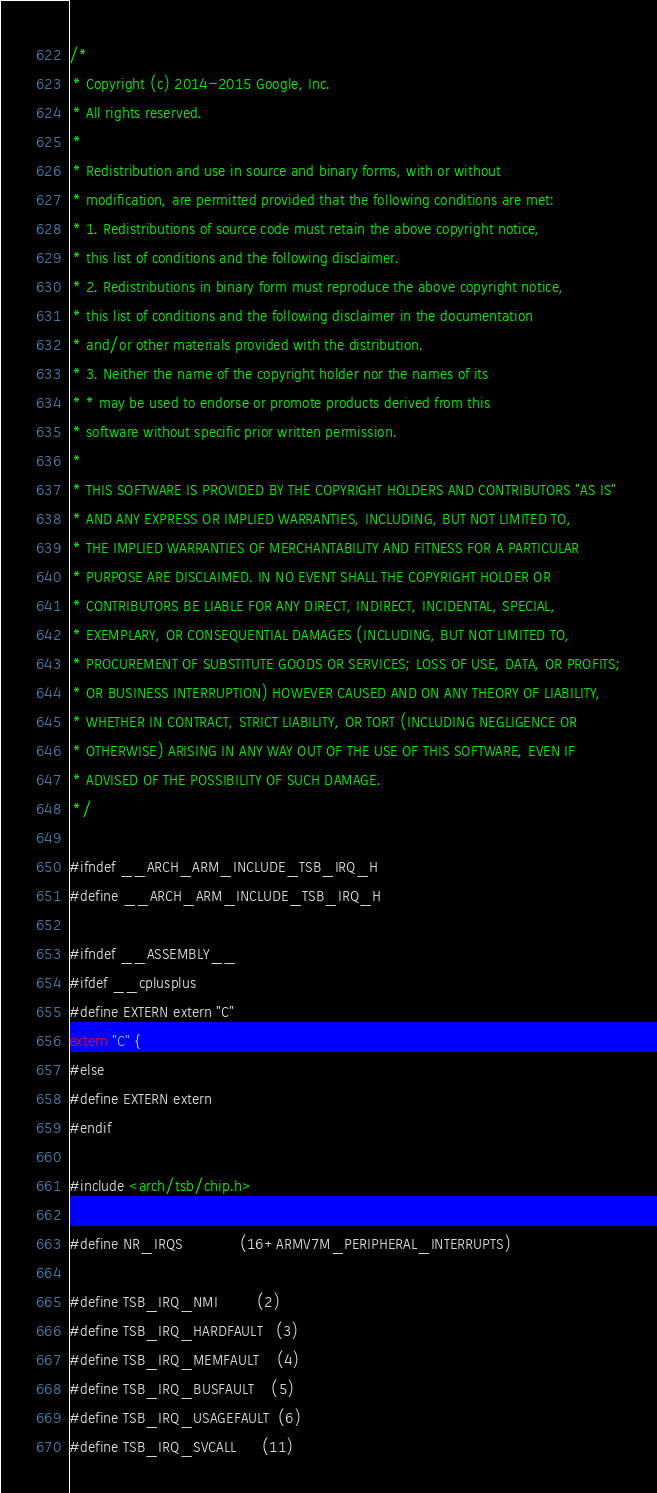Convert code to text. <code><loc_0><loc_0><loc_500><loc_500><_C_>/*
 * Copyright (c) 2014-2015 Google, Inc.
 * All rights reserved.
 *
 * Redistribution and use in source and binary forms, with or without
 * modification, are permitted provided that the following conditions are met:
 * 1. Redistributions of source code must retain the above copyright notice,
 * this list of conditions and the following disclaimer.
 * 2. Redistributions in binary form must reproduce the above copyright notice,
 * this list of conditions and the following disclaimer in the documentation
 * and/or other materials provided with the distribution.
 * 3. Neither the name of the copyright holder nor the names of its
 * * may be used to endorse or promote products derived from this
 * software without specific prior written permission.
 *
 * THIS SOFTWARE IS PROVIDED BY THE COPYRIGHT HOLDERS AND CONTRIBUTORS "AS IS"
 * AND ANY EXPRESS OR IMPLIED WARRANTIES, INCLUDING, BUT NOT LIMITED TO,
 * THE IMPLIED WARRANTIES OF MERCHANTABILITY AND FITNESS FOR A PARTICULAR
 * PURPOSE ARE DISCLAIMED. IN NO EVENT SHALL THE COPYRIGHT HOLDER OR
 * CONTRIBUTORS BE LIABLE FOR ANY DIRECT, INDIRECT, INCIDENTAL, SPECIAL,
 * EXEMPLARY, OR CONSEQUENTIAL DAMAGES (INCLUDING, BUT NOT LIMITED TO,
 * PROCUREMENT OF SUBSTITUTE GOODS OR SERVICES; LOSS OF USE, DATA, OR PROFITS;
 * OR BUSINESS INTERRUPTION) HOWEVER CAUSED AND ON ANY THEORY OF LIABILITY,
 * WHETHER IN CONTRACT, STRICT LIABILITY, OR TORT (INCLUDING NEGLIGENCE OR
 * OTHERWISE) ARISING IN ANY WAY OUT OF THE USE OF THIS SOFTWARE, EVEN IF
 * ADVISED OF THE POSSIBILITY OF SUCH DAMAGE.
 */

#ifndef __ARCH_ARM_INCLUDE_TSB_IRQ_H
#define __ARCH_ARM_INCLUDE_TSB_IRQ_H

#ifndef __ASSEMBLY__
#ifdef __cplusplus
#define EXTERN extern "C"
extern "C" {
#else
#define EXTERN extern
#endif

#include <arch/tsb/chip.h>

#define NR_IRQS             (16+ARMV7M_PERIPHERAL_INTERRUPTS)

#define TSB_IRQ_NMI         (2)
#define TSB_IRQ_HARDFAULT   (3)
#define TSB_IRQ_MEMFAULT    (4)
#define TSB_IRQ_BUSFAULT    (5)
#define TSB_IRQ_USAGEFAULT  (6)
#define TSB_IRQ_SVCALL      (11)</code> 